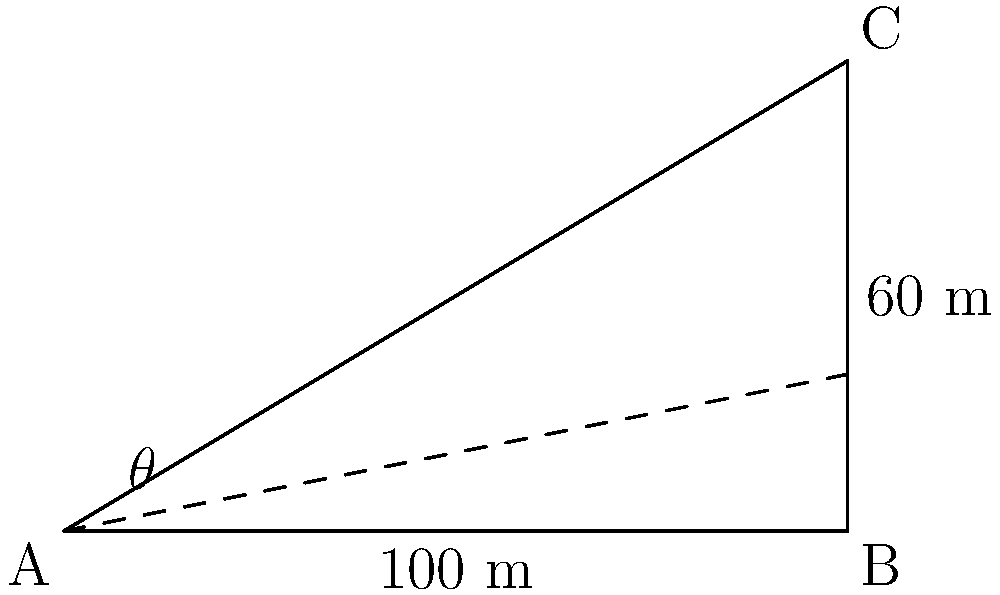In a city with diverse religious structures, two buildings representing different faiths stand adjacent to each other. From the base of the shorter building (point A), the top of the taller building (point C) is visible at an angle of elevation. The distance between the bases of the two buildings is 100 meters, and the height difference between them is 60 meters. Calculate the angle of elevation ($\theta$) from the base of the shorter building to the top of the taller one. Round your answer to the nearest degree. To solve this problem, we'll use trigonometry, specifically the tangent function. Let's approach this step-by-step:

1) In the right triangle ABC:
   - The adjacent side (AB) is 100 meters
   - The opposite side (BC) is 60 meters
   - We need to find the angle $\theta$

2) The tangent of an angle in a right triangle is defined as the ratio of the opposite side to the adjacent side:

   $\tan(\theta) = \frac{\text{opposite}}{\text{adjacent}}$

3) Substituting our values:

   $\tan(\theta) = \frac{60}{100} = 0.6$

4) To find $\theta$, we need to use the inverse tangent (arctan or $\tan^{-1}$):

   $\theta = \tan^{-1}(0.6)$

5) Using a calculator or trigonometric tables:

   $\theta \approx 30.96^\circ$

6) Rounding to the nearest degree:

   $\theta \approx 31^\circ$

This angle represents the elevation from which an observer at the base of the shorter building would view the top of the taller building, providing a quantitative measure of their relative heights and positions.
Answer: $31^\circ$ 